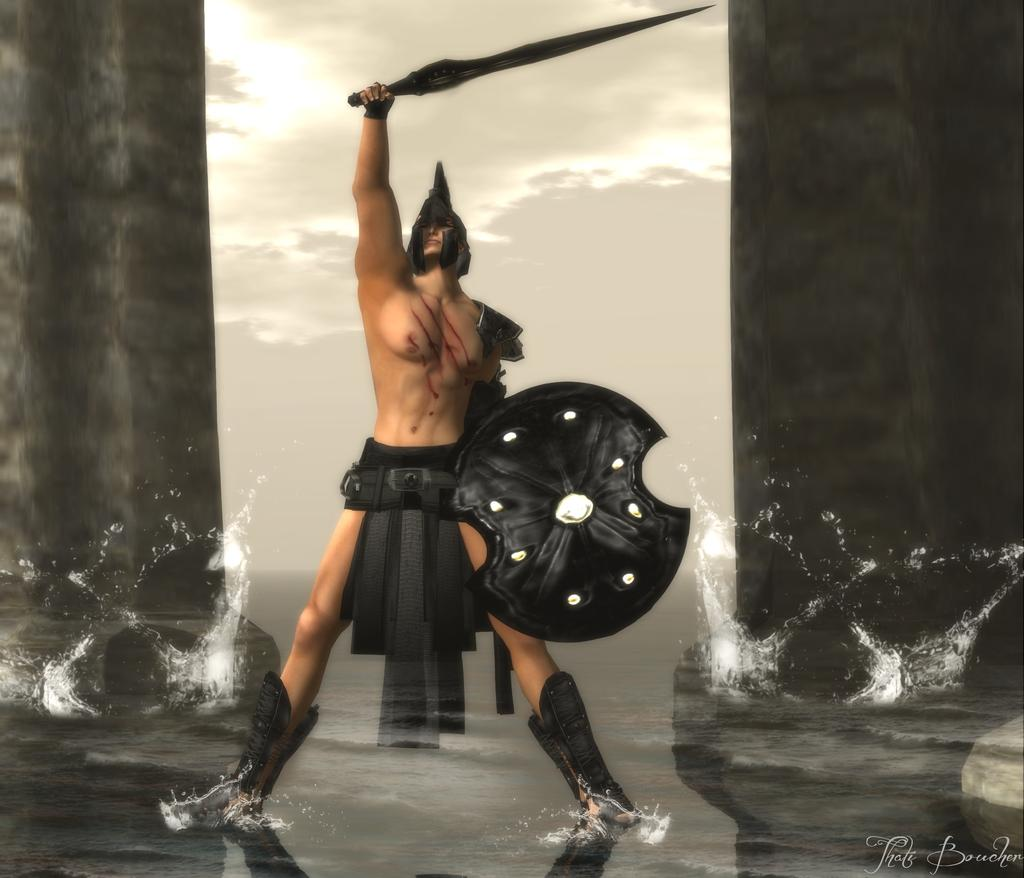What is depicted in the image that represents a natural element? There is a depiction of water in the image. What are the people in the image holding? There is a depiction of a person with a shield and a person with a sword in the image. Is there any additional information or marking visible in the image? Yes, there is a watermark visible in the image. What type of pump can be seen in the image? There is no pump present in the image. How many twigs are visible in the image? There are no twigs visible in the image. 